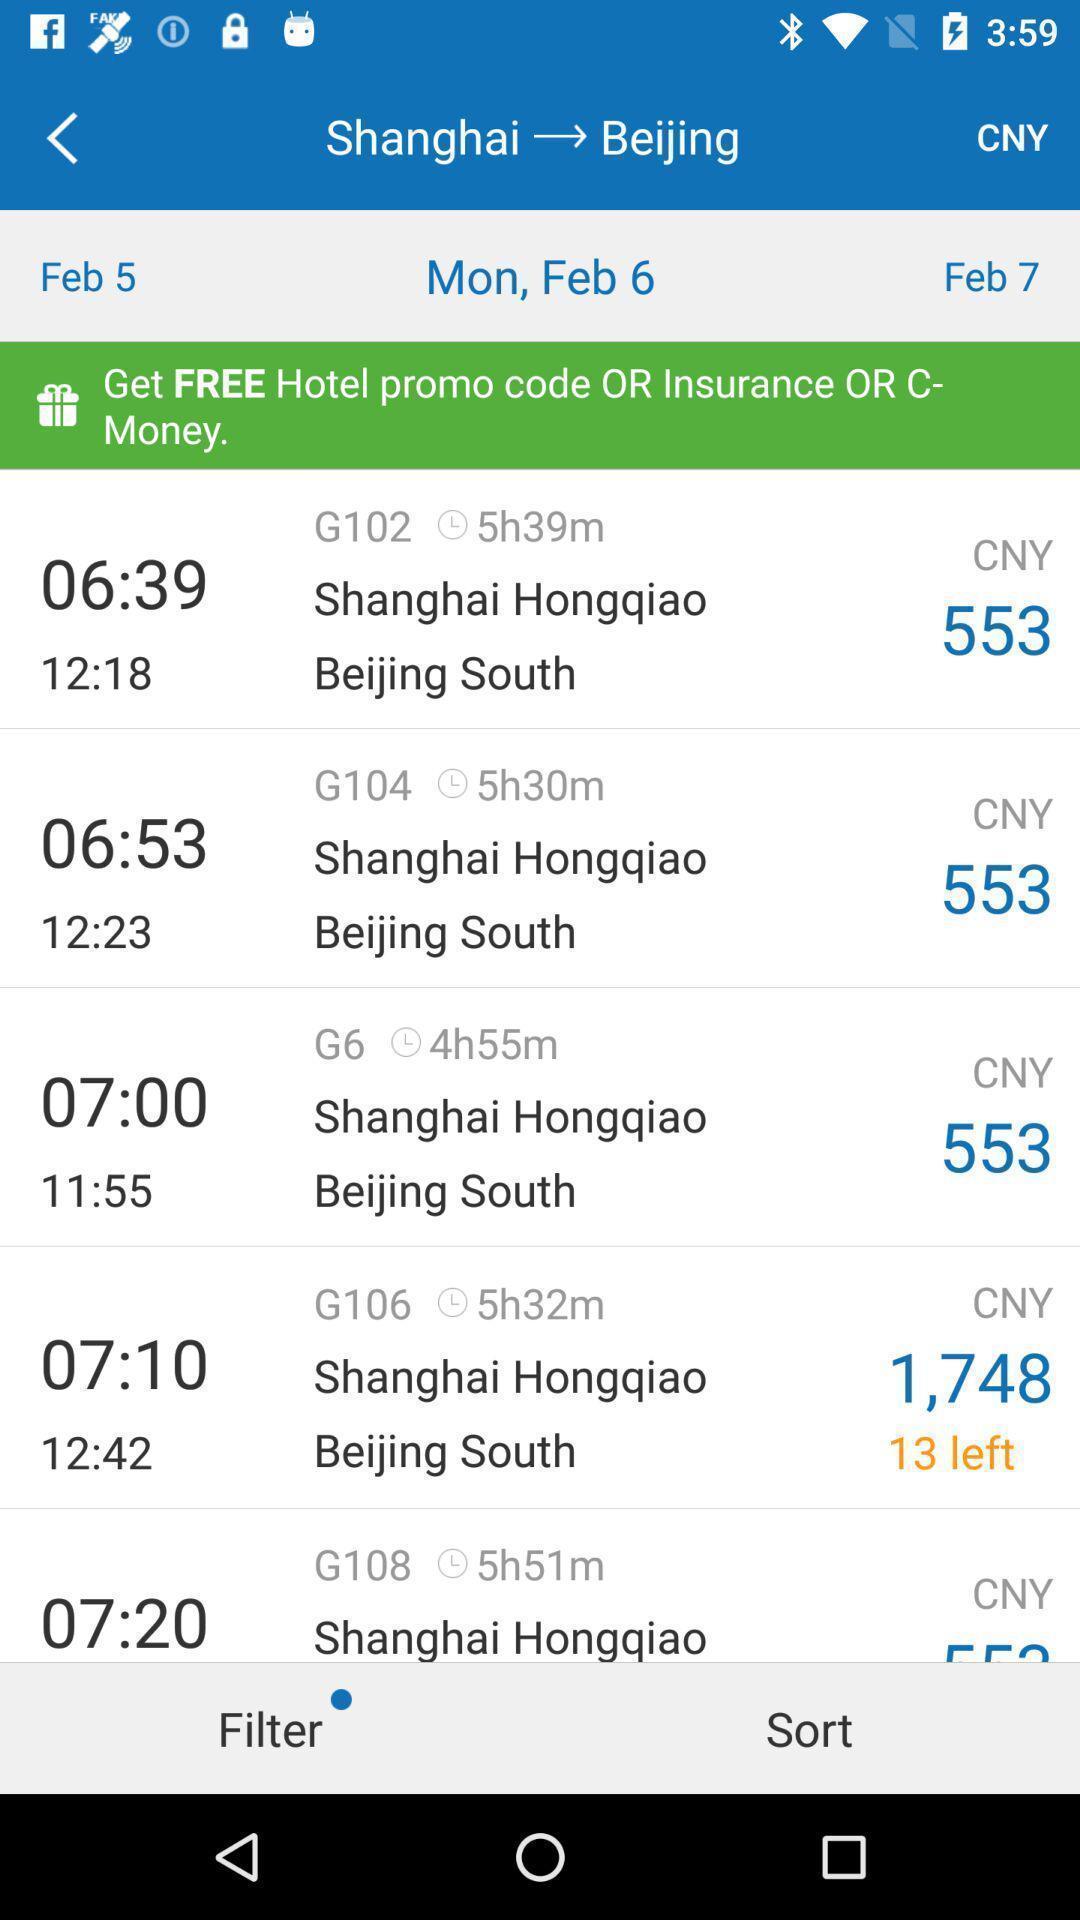Tell me what you see in this picture. Screen shows list of timings information in travel app. 